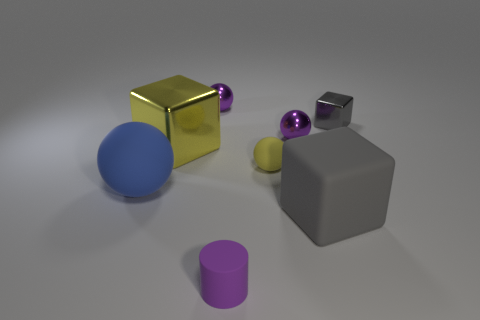What shape is the large gray rubber object to the right of the big yellow metal object? cube 